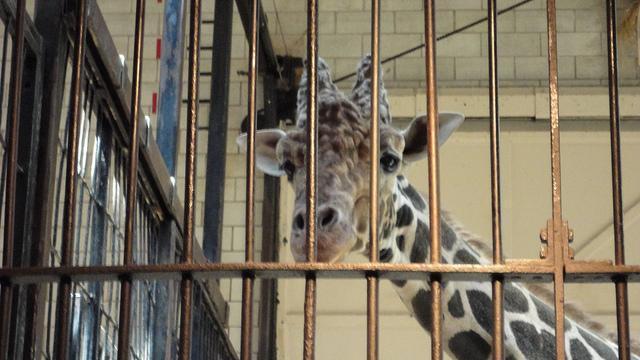How many giraffes are there?
Give a very brief answer. 1. How many giraffes are in the picture?
Give a very brief answer. 1. How many people are currently playing?
Give a very brief answer. 0. 